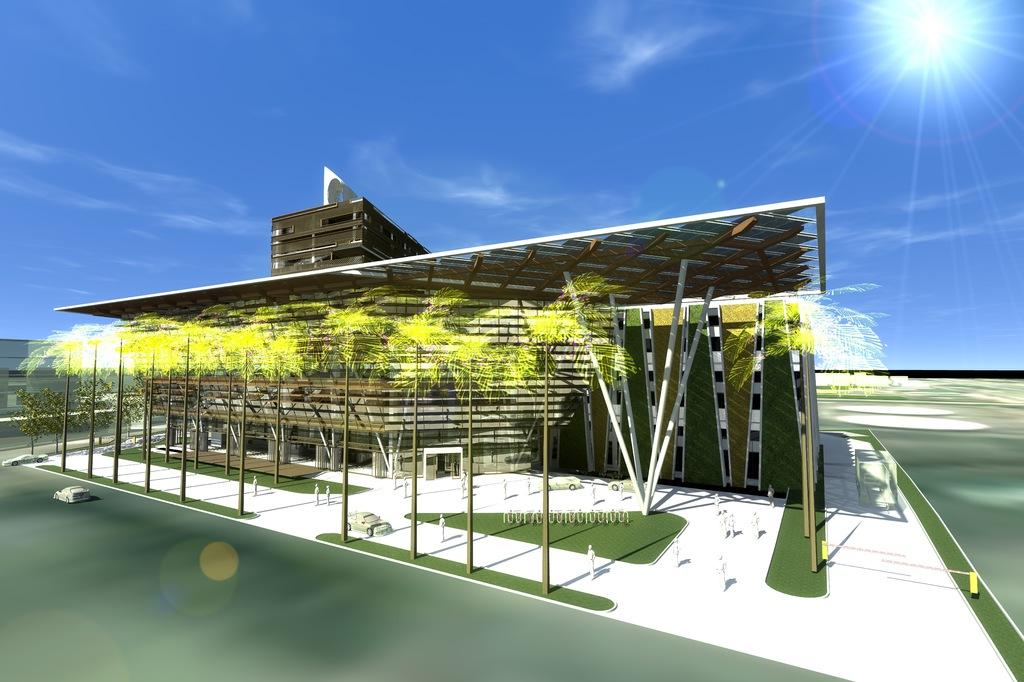What type of document is shown in the image? The image is a blueprint. What is the main subject of the blueprint? There is a building depicted in the blueprint. Are there any people depicted in the blueprint? Yes, there is a person depicted in the blueprint. What other natural elements are present in the blueprint? There are trees depicted in the blueprint. What is visible in the background of the blueprint? The background of the blueprint includes sky and clouds. What is happening at the bottom of the blueprint? At the bottom of the blueprint, there are cars on the road. What type of bird can be seen stitching the trees in the image? There is no bird present in the image, let alone one that is stitching trees. 